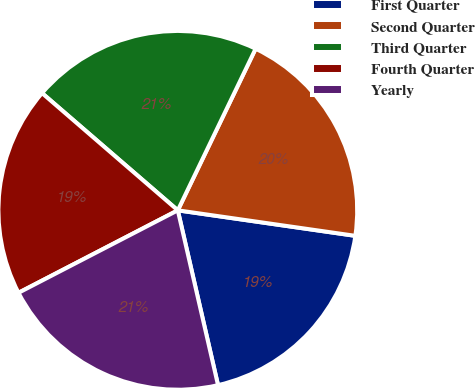Convert chart. <chart><loc_0><loc_0><loc_500><loc_500><pie_chart><fcel>First Quarter<fcel>Second Quarter<fcel>Third Quarter<fcel>Fourth Quarter<fcel>Yearly<nl><fcel>19.13%<fcel>20.13%<fcel>20.81%<fcel>18.94%<fcel>21.0%<nl></chart> 